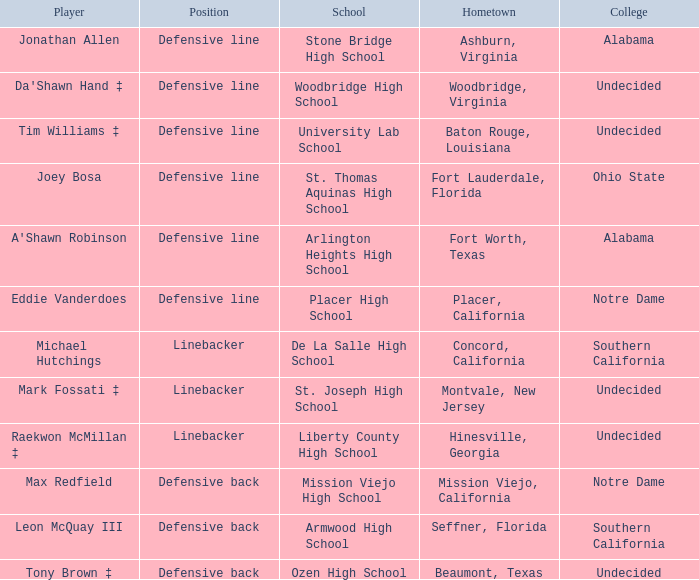Could you help me parse every detail presented in this table? {'header': ['Player', 'Position', 'School', 'Hometown', 'College'], 'rows': [['Jonathan Allen', 'Defensive line', 'Stone Bridge High School', 'Ashburn, Virginia', 'Alabama'], ["Da'Shawn Hand ‡", 'Defensive line', 'Woodbridge High School', 'Woodbridge, Virginia', 'Undecided'], ['Tim Williams ‡', 'Defensive line', 'University Lab School', 'Baton Rouge, Louisiana', 'Undecided'], ['Joey Bosa', 'Defensive line', 'St. Thomas Aquinas High School', 'Fort Lauderdale, Florida', 'Ohio State'], ["A'Shawn Robinson", 'Defensive line', 'Arlington Heights High School', 'Fort Worth, Texas', 'Alabama'], ['Eddie Vanderdoes', 'Defensive line', 'Placer High School', 'Placer, California', 'Notre Dame'], ['Michael Hutchings', 'Linebacker', 'De La Salle High School', 'Concord, California', 'Southern California'], ['Mark Fossati ‡', 'Linebacker', 'St. Joseph High School', 'Montvale, New Jersey', 'Undecided'], ['Raekwon McMillan ‡', 'Linebacker', 'Liberty County High School', 'Hinesville, Georgia', 'Undecided'], ['Max Redfield', 'Defensive back', 'Mission Viejo High School', 'Mission Viejo, California', 'Notre Dame'], ['Leon McQuay III', 'Defensive back', 'Armwood High School', 'Seffner, Florida', 'Southern California'], ['Tony Brown ‡', 'Defensive back', 'Ozen High School', 'Beaumont, Texas', 'Undecided']]} In which position did max redfield participate? Defensive back. 